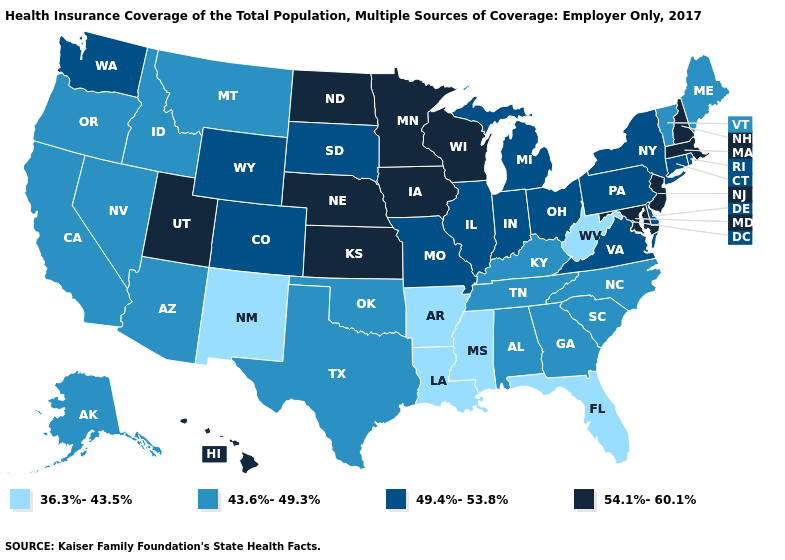What is the value of Colorado?
Quick response, please. 49.4%-53.8%. Which states have the lowest value in the South?
Short answer required. Arkansas, Florida, Louisiana, Mississippi, West Virginia. What is the value of Hawaii?
Give a very brief answer. 54.1%-60.1%. What is the value of Delaware?
Short answer required. 49.4%-53.8%. Does Georgia have the same value as Alaska?
Short answer required. Yes. Is the legend a continuous bar?
Concise answer only. No. Does the first symbol in the legend represent the smallest category?
Be succinct. Yes. Name the states that have a value in the range 49.4%-53.8%?
Short answer required. Colorado, Connecticut, Delaware, Illinois, Indiana, Michigan, Missouri, New York, Ohio, Pennsylvania, Rhode Island, South Dakota, Virginia, Washington, Wyoming. Does Pennsylvania have a higher value than Texas?
Write a very short answer. Yes. What is the value of Mississippi?
Be succinct. 36.3%-43.5%. How many symbols are there in the legend?
Give a very brief answer. 4. What is the value of New York?
Write a very short answer. 49.4%-53.8%. What is the value of Indiana?
Answer briefly. 49.4%-53.8%. Does Mississippi have the lowest value in the South?
Answer briefly. Yes. Does Arizona have the lowest value in the USA?
Give a very brief answer. No. 